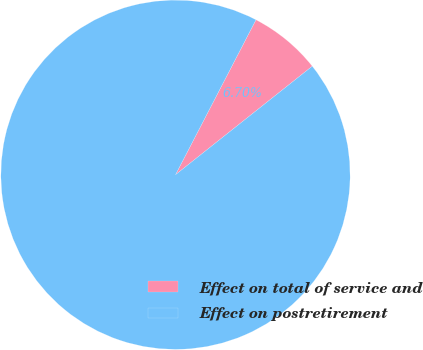Convert chart. <chart><loc_0><loc_0><loc_500><loc_500><pie_chart><fcel>Effect on total of service and<fcel>Effect on postretirement<nl><fcel>6.7%<fcel>93.3%<nl></chart> 